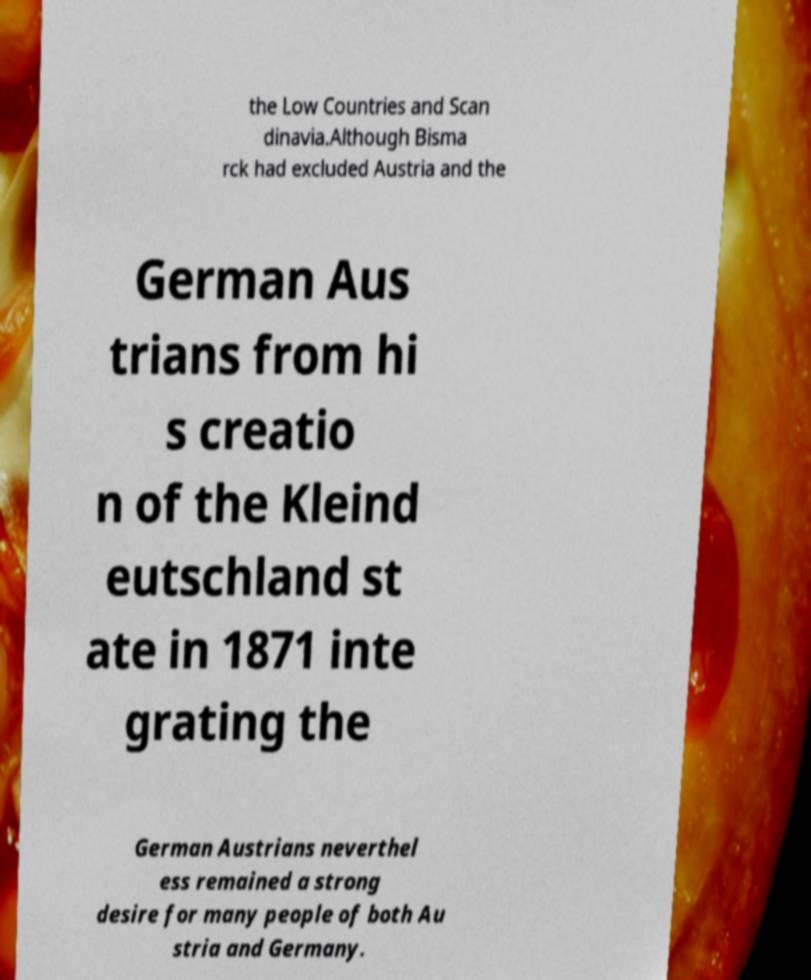There's text embedded in this image that I need extracted. Can you transcribe it verbatim? the Low Countries and Scan dinavia.Although Bisma rck had excluded Austria and the German Aus trians from hi s creatio n of the Kleind eutschland st ate in 1871 inte grating the German Austrians neverthel ess remained a strong desire for many people of both Au stria and Germany. 